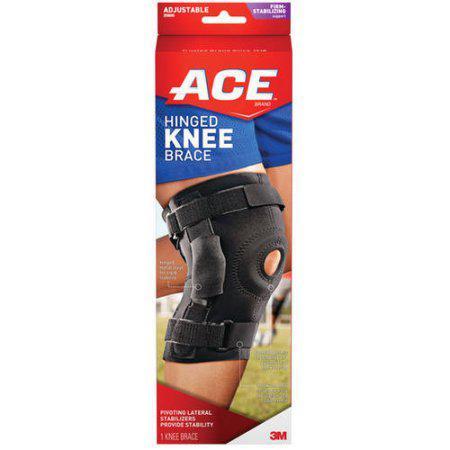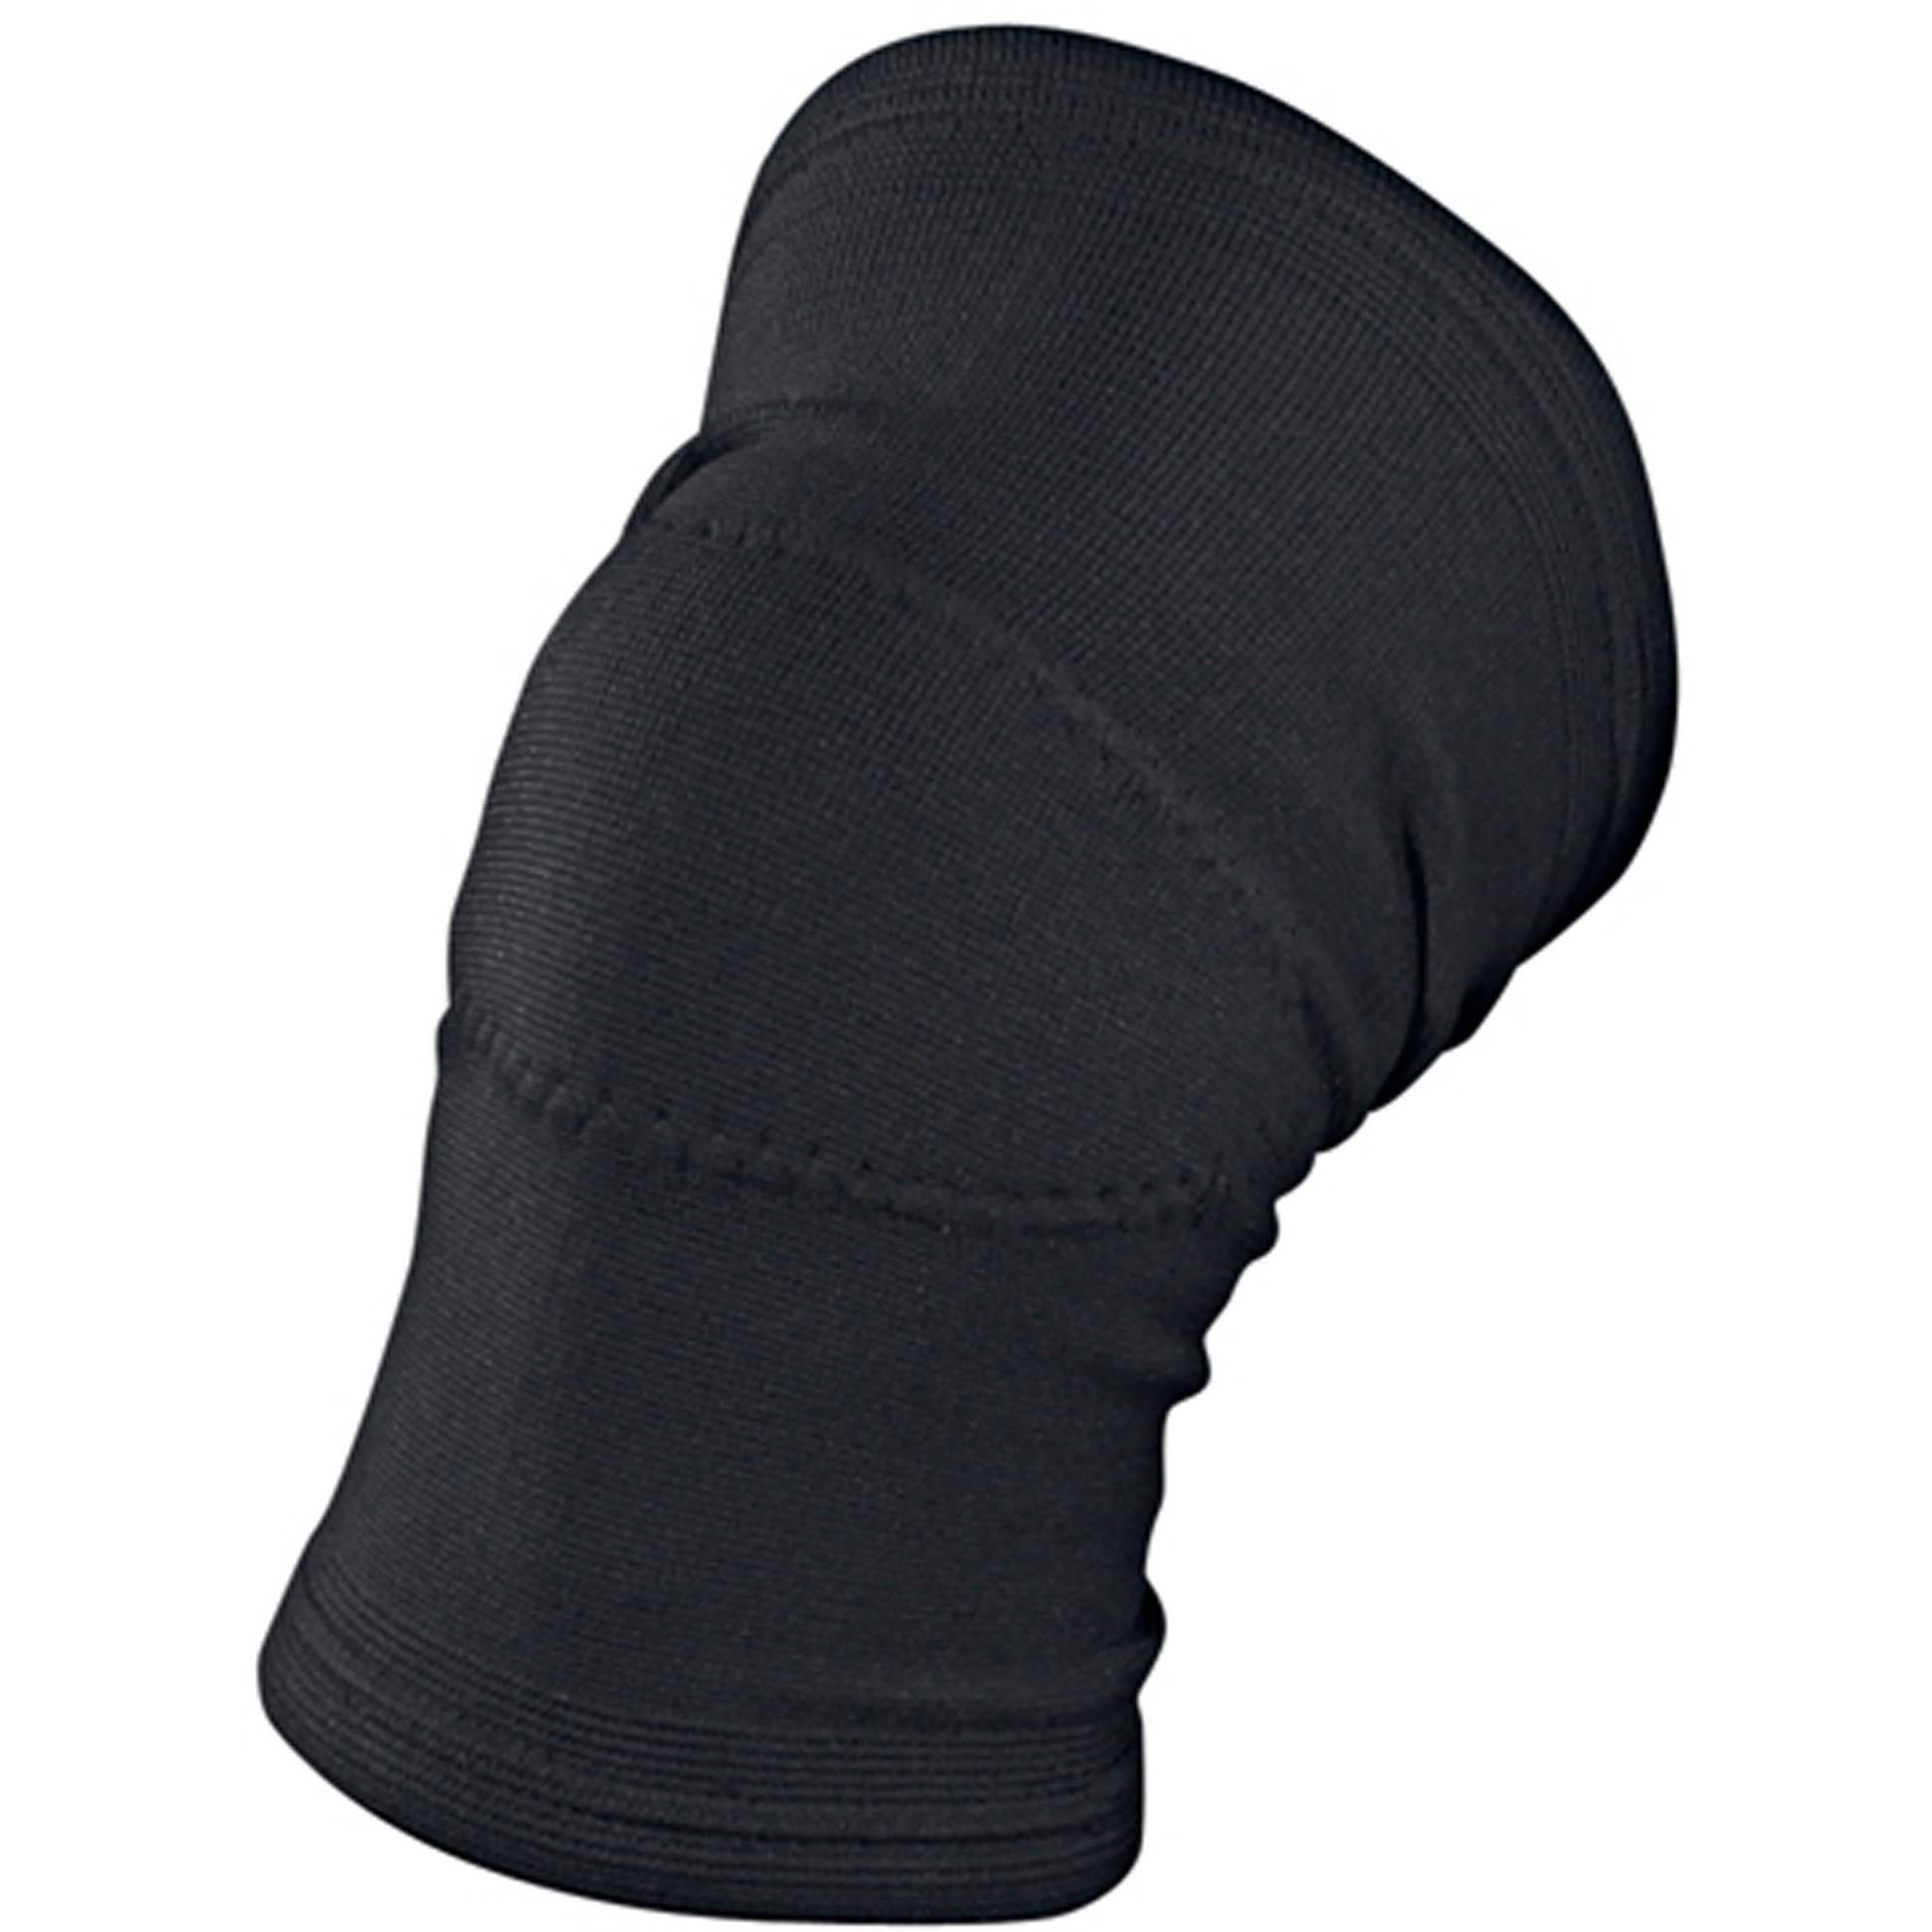The first image is the image on the left, the second image is the image on the right. Assess this claim about the two images: "One of the images shows exactly two knee braces.". Correct or not? Answer yes or no. No. The first image is the image on the left, the second image is the image on the right. For the images displayed, is the sentence "One of the images features a knee pad still in its red packaging" factually correct? Answer yes or no. Yes. The first image is the image on the left, the second image is the image on the right. Assess this claim about the two images: "One image shows the knee brace package.". Correct or not? Answer yes or no. Yes. 